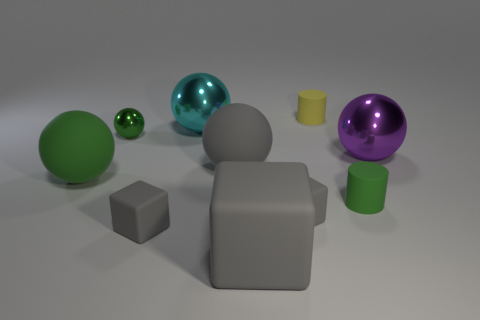Subtract all cyan cubes. How many green balls are left? 2 Subtract all green balls. How many balls are left? 3 Subtract all big gray rubber spheres. How many spheres are left? 4 Subtract all cylinders. How many objects are left? 8 Subtract all yellow spheres. Subtract all purple cubes. How many spheres are left? 5 Subtract all green rubber balls. Subtract all large blocks. How many objects are left? 8 Add 1 green metallic balls. How many green metallic balls are left? 2 Add 2 big purple balls. How many big purple balls exist? 3 Subtract 0 cyan cubes. How many objects are left? 10 